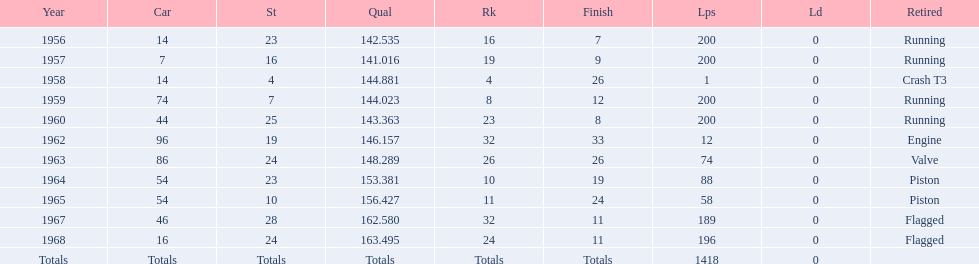Indicate the number of moments he concluded over 10th rank. 3. 